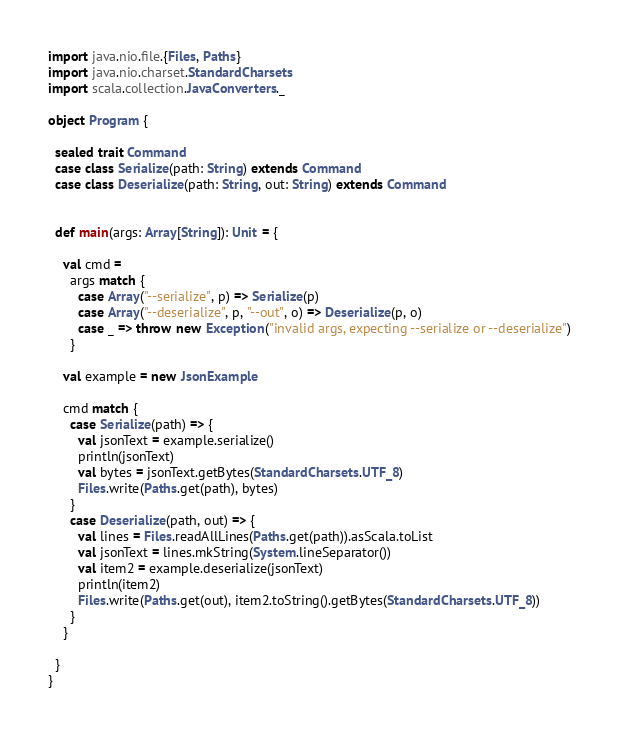<code> <loc_0><loc_0><loc_500><loc_500><_Scala_>import java.nio.file.{Files, Paths}
import java.nio.charset.StandardCharsets
import scala.collection.JavaConverters._

object Program {

  sealed trait Command
  case class Serialize(path: String) extends Command
  case class Deserialize(path: String, out: String) extends Command


  def main(args: Array[String]): Unit = {

    val cmd =
      args match {
        case Array("--serialize", p) => Serialize(p)
        case Array("--deserialize", p, "--out", o) => Deserialize(p, o)
        case _ => throw new Exception("invalid args, expecting --serialize or --deserialize")
      }

    val example = new JsonExample

    cmd match {
      case Serialize(path) => {
        val jsonText = example.serialize()
        println(jsonText)
        val bytes = jsonText.getBytes(StandardCharsets.UTF_8)
        Files.write(Paths.get(path), bytes)
      }
      case Deserialize(path, out) => {
        val lines = Files.readAllLines(Paths.get(path)).asScala.toList
        val jsonText = lines.mkString(System.lineSeparator())
        val item2 = example.deserialize(jsonText)
        println(item2)
        Files.write(Paths.get(out), item2.toString().getBytes(StandardCharsets.UTF_8))
      }
    }

  }
}
</code> 